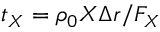Convert formula to latex. <formula><loc_0><loc_0><loc_500><loc_500>t _ { X } = \rho _ { 0 } X \Delta r / F _ { X }</formula> 